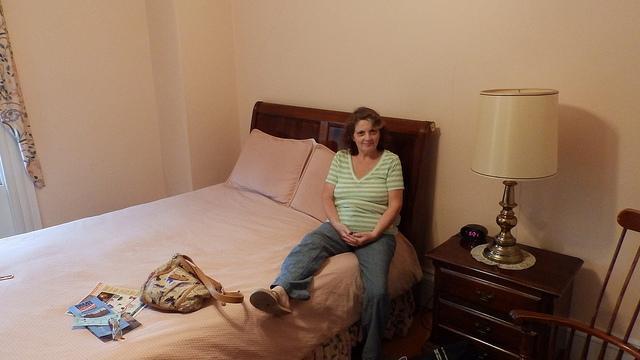How many light sources are in the room?
Give a very brief answer. 1. How many cats are on the bed?
Give a very brief answer. 0. How many babies are there?
Give a very brief answer. 0. How many zebras are facing the camera?
Give a very brief answer. 0. 